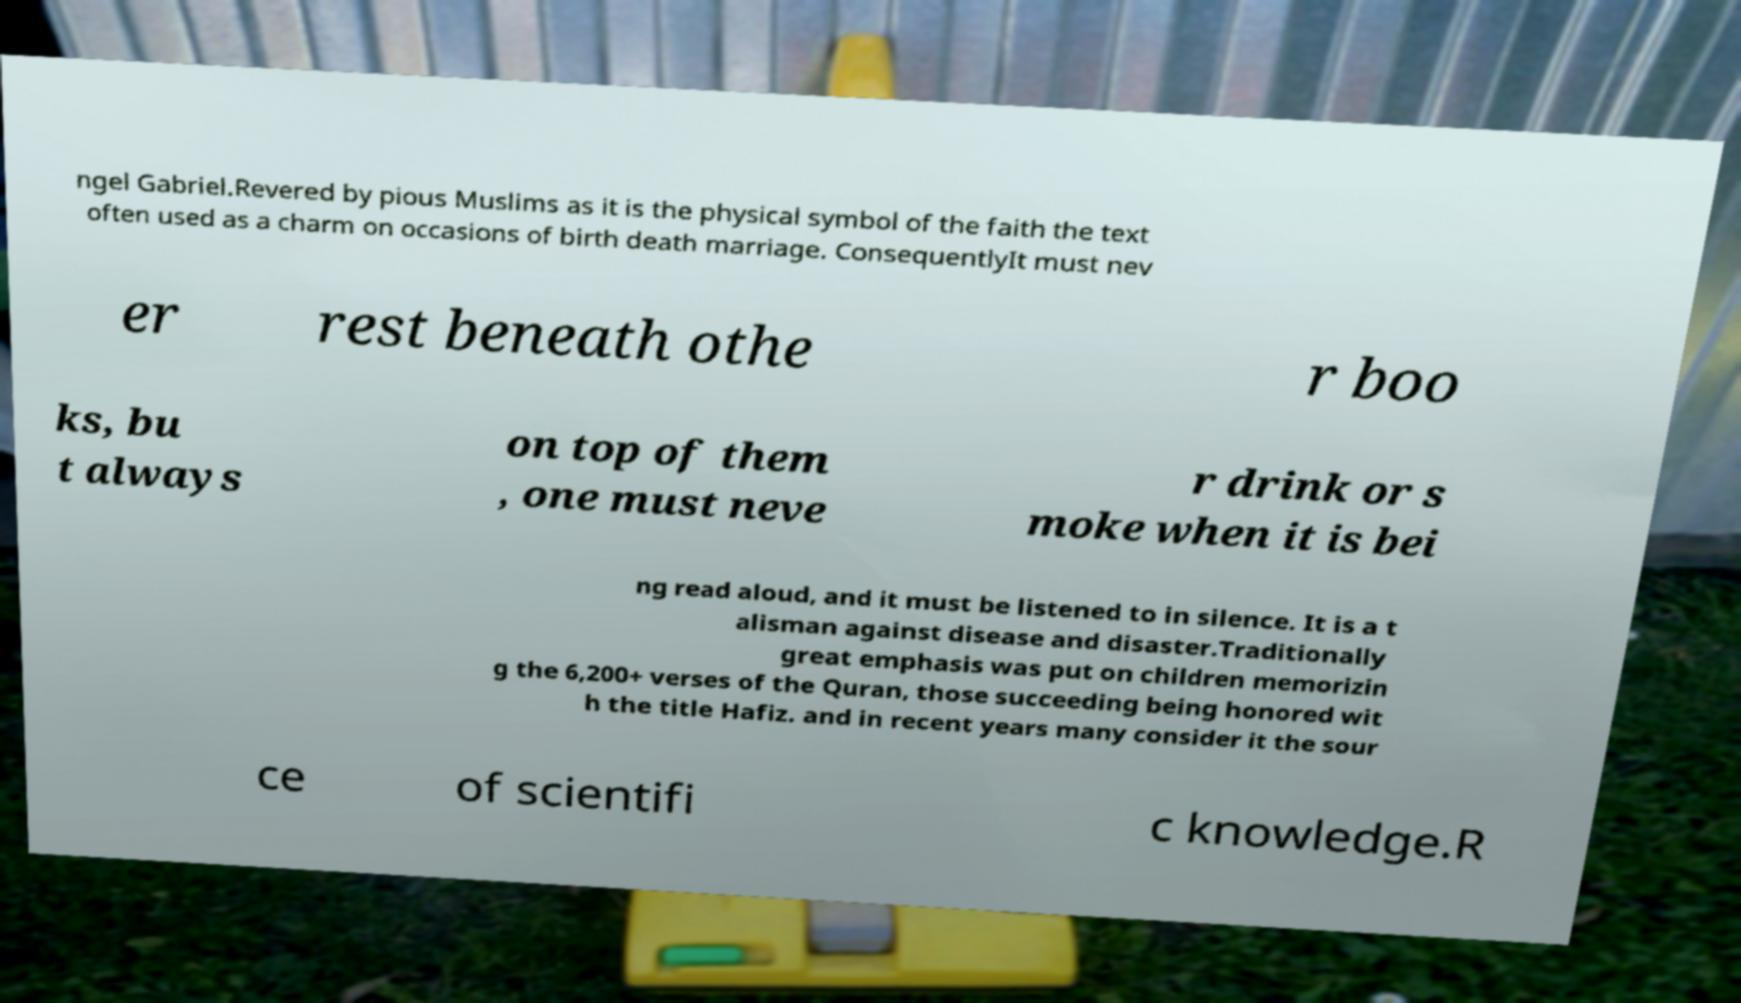Can you read and provide the text displayed in the image?This photo seems to have some interesting text. Can you extract and type it out for me? ngel Gabriel.Revered by pious Muslims as it is the physical symbol of the faith the text often used as a charm on occasions of birth death marriage. ConsequentlyIt must nev er rest beneath othe r boo ks, bu t always on top of them , one must neve r drink or s moke when it is bei ng read aloud, and it must be listened to in silence. It is a t alisman against disease and disaster.Traditionally great emphasis was put on children memorizin g the 6,200+ verses of the Quran, those succeeding being honored wit h the title Hafiz. and in recent years many consider it the sour ce of scientifi c knowledge.R 